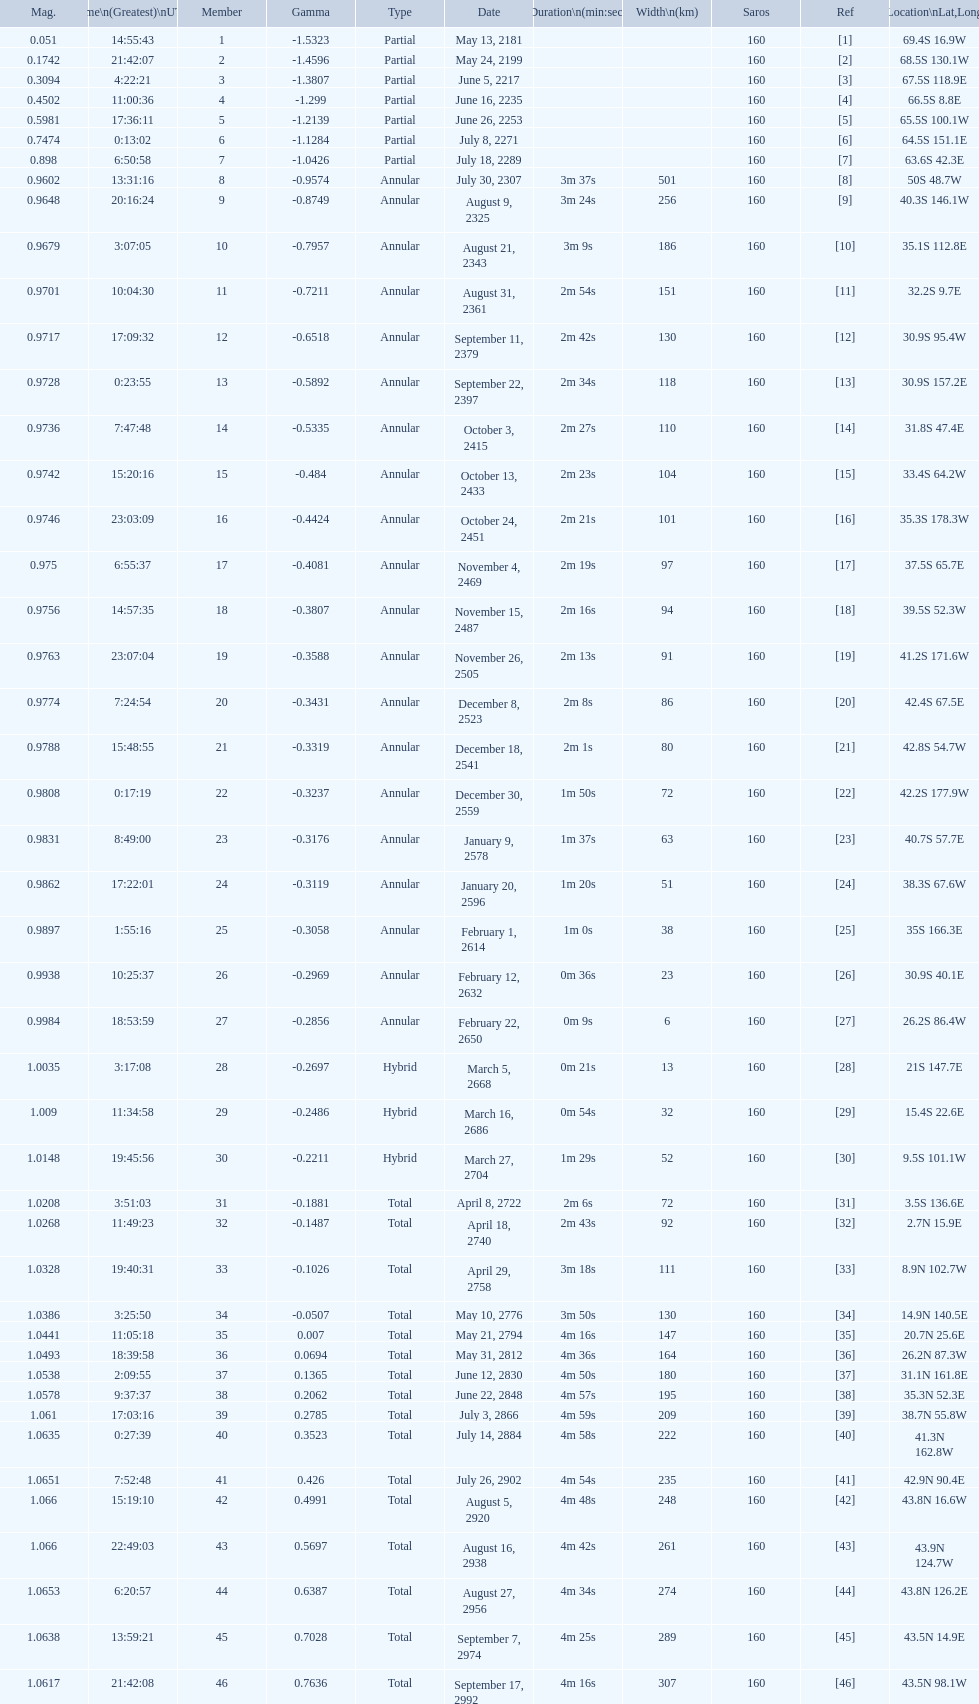How long did the the saros on july 30, 2307 last for? 3m 37s. 